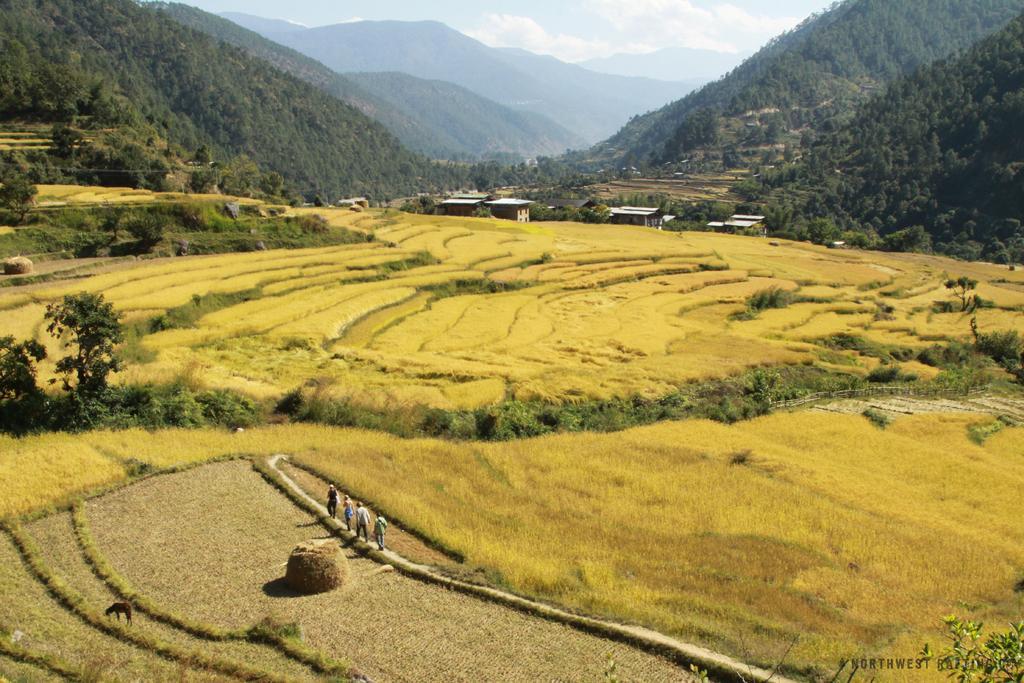Could you give a brief overview of what you see in this image? In this picture we can see people on a path, beside this path we can see fields, trees and some objects and in the background we can see sheds, mountains and sky with clouds. 